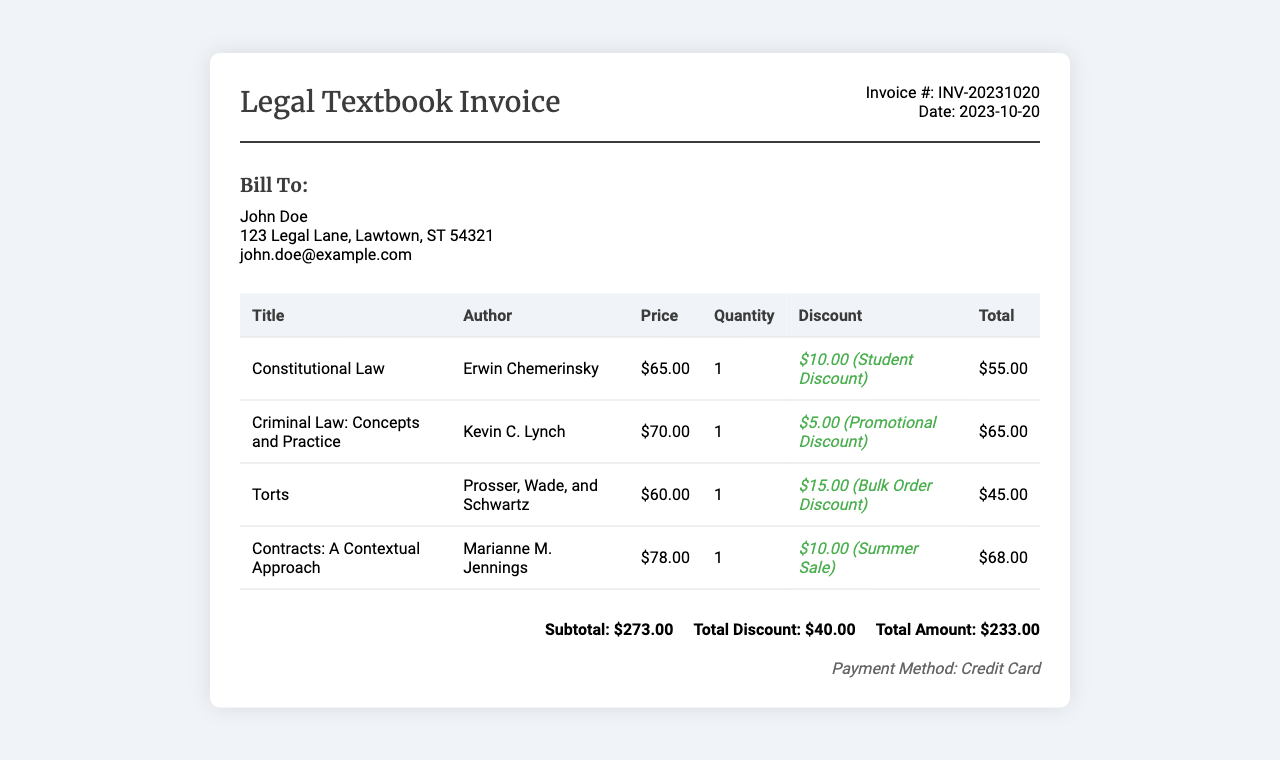What is the invoice number? The invoice number is clearly listed in the document and refers to the specific transaction.
Answer: INV-20231020 Who is the author of "Torts"? The author of "Torts" is named in the invoice and is essential for identifying the context of the textbook.
Answer: Prosser, Wade, and Schwartz What is the total discount applied? The total discount is the sum of all applied discounts in the invoice, which is manually computed from the listed discounts.
Answer: $40.00 What is the total amount due? The total amount due summarizes the overall cost after applying discounts, as indicated at the bottom of the invoice.
Answer: $233.00 What payment method was used? The payment method is explicitly mentioned in the document and gives insight into how the transaction was completed.
Answer: Credit Card What is the price of "Constitutional Law"? The price listed shows how much the customer will pay for the specific textbook, which is important for budgeting.
Answer: $65.00 Which textbook received a bulk order discount? This question requires an understanding of the discounts provided and their relevant textbooks, which is noted in the details.
Answer: Torts What date was the invoice issued? The date indicates when the transaction took place or when the invoice was created.
Answer: 2023-10-20 